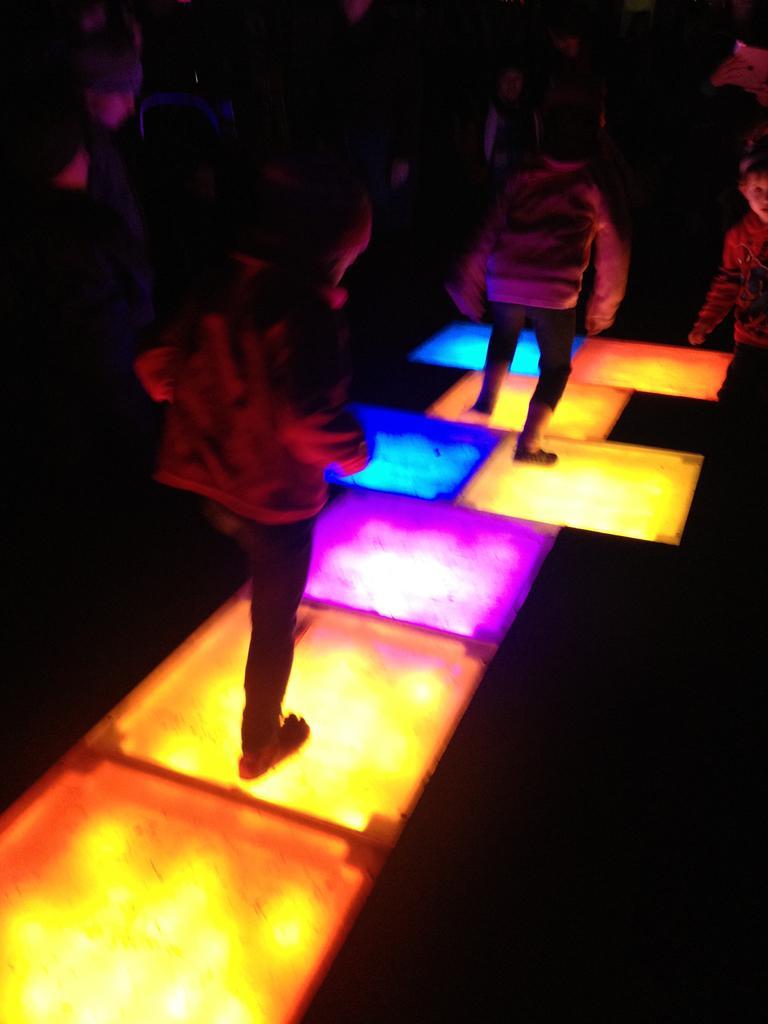Can you describe this image briefly? In this picture couple of them standing on the lighting floor and a girl standing on the side. 